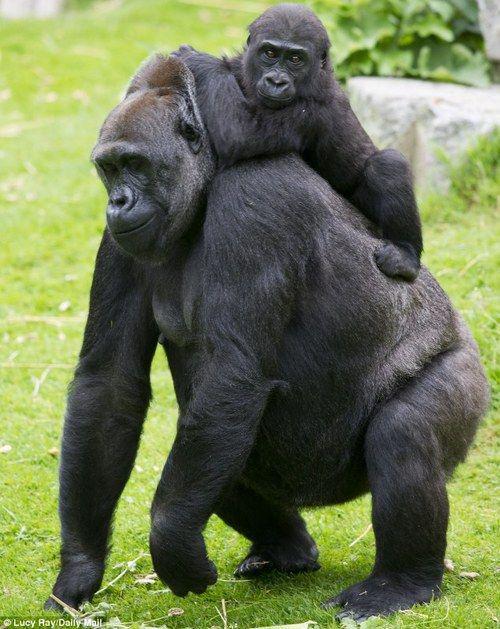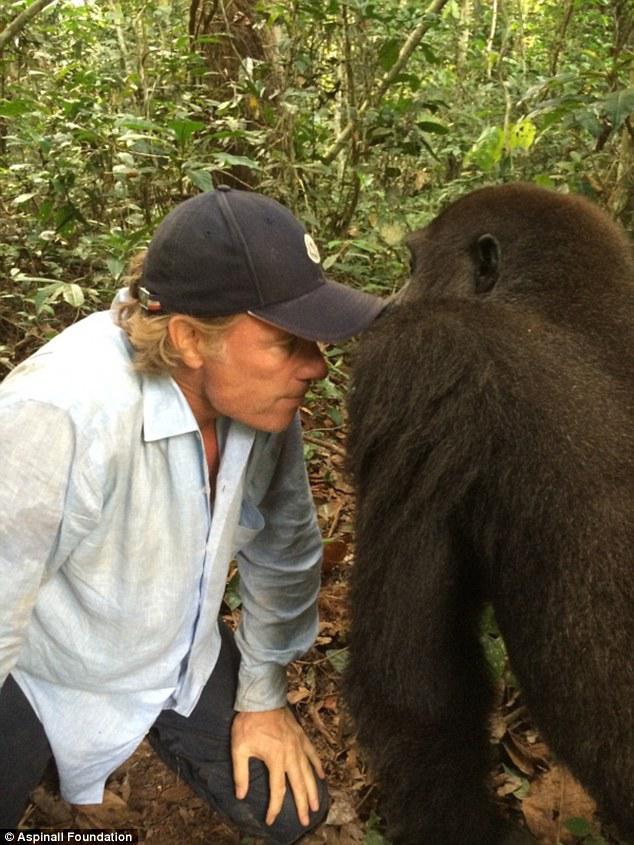The first image is the image on the left, the second image is the image on the right. Evaluate the accuracy of this statement regarding the images: "An image features one person gazing into the face of a large ape.". Is it true? Answer yes or no. Yes. The first image is the image on the left, the second image is the image on the right. Given the left and right images, does the statement "The right photo shows an adult gorilla interacting with a human being" hold true? Answer yes or no. Yes. 